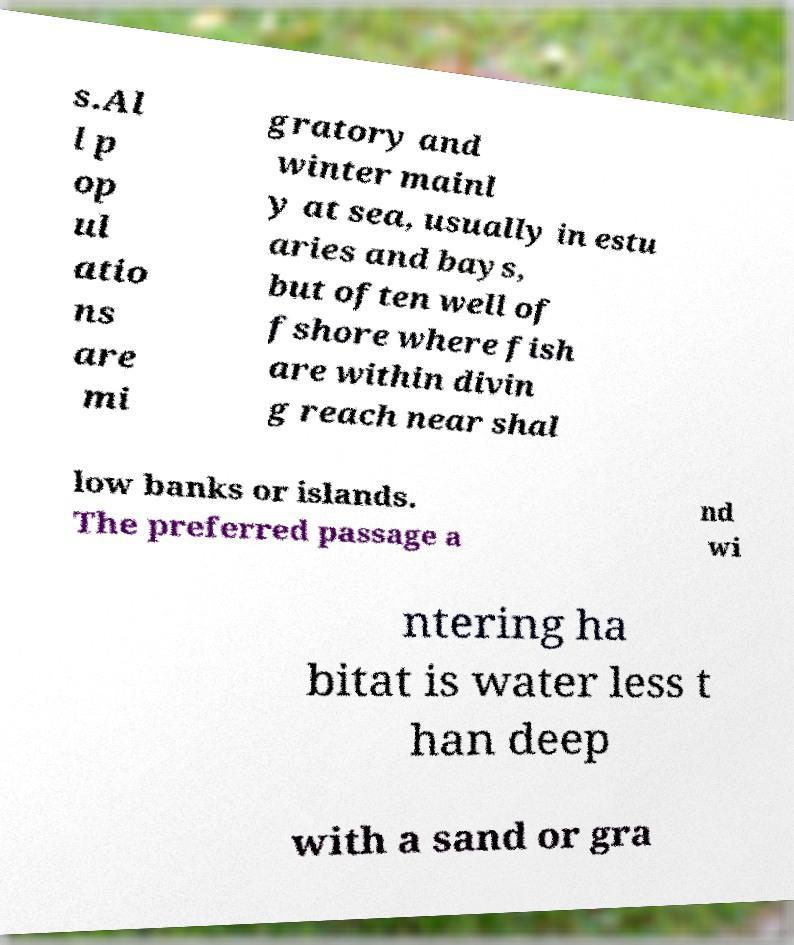Please identify and transcribe the text found in this image. s.Al l p op ul atio ns are mi gratory and winter mainl y at sea, usually in estu aries and bays, but often well of fshore where fish are within divin g reach near shal low banks or islands. The preferred passage a nd wi ntering ha bitat is water less t han deep with a sand or gra 